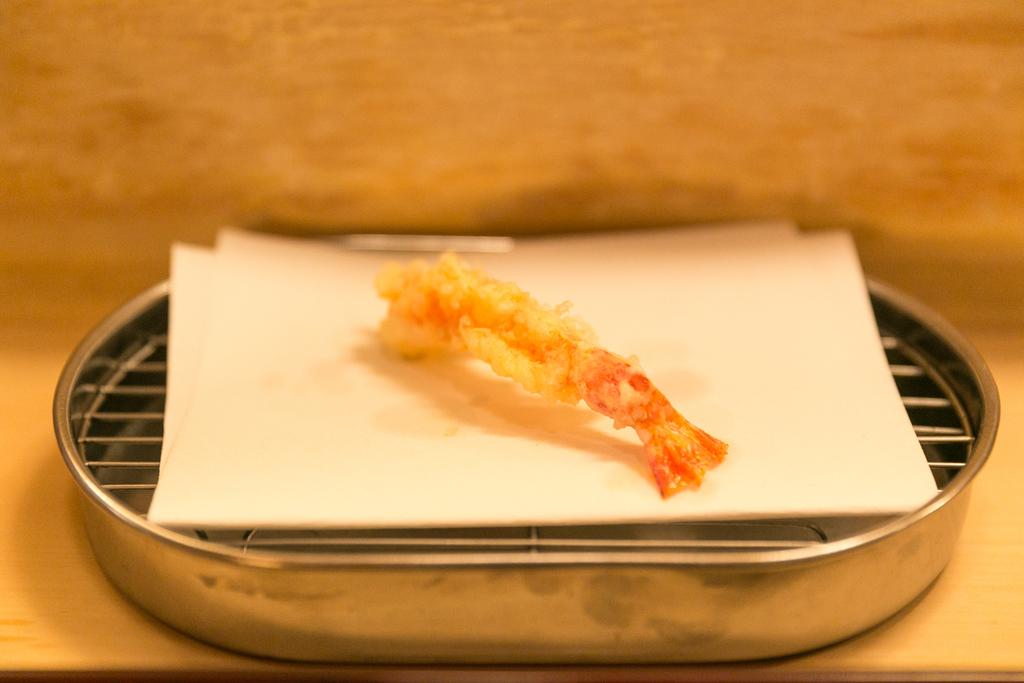What type of surface is visible in the image? There is a wooden surface in the image. What is placed on the wooden surface? There is a metal grill plate on the wooden surface. What is on top of the metal grill plate? There is a tissue on the metal grill plate. What is on the tissue? There is a food item on the tissue. How many buildings can be seen in the image? There are no buildings visible in the image. How long does it take for the food item to be consumed in the image? The image does not show the food item being consumed, so it is impossible to determine how long it takes to be eaten. 